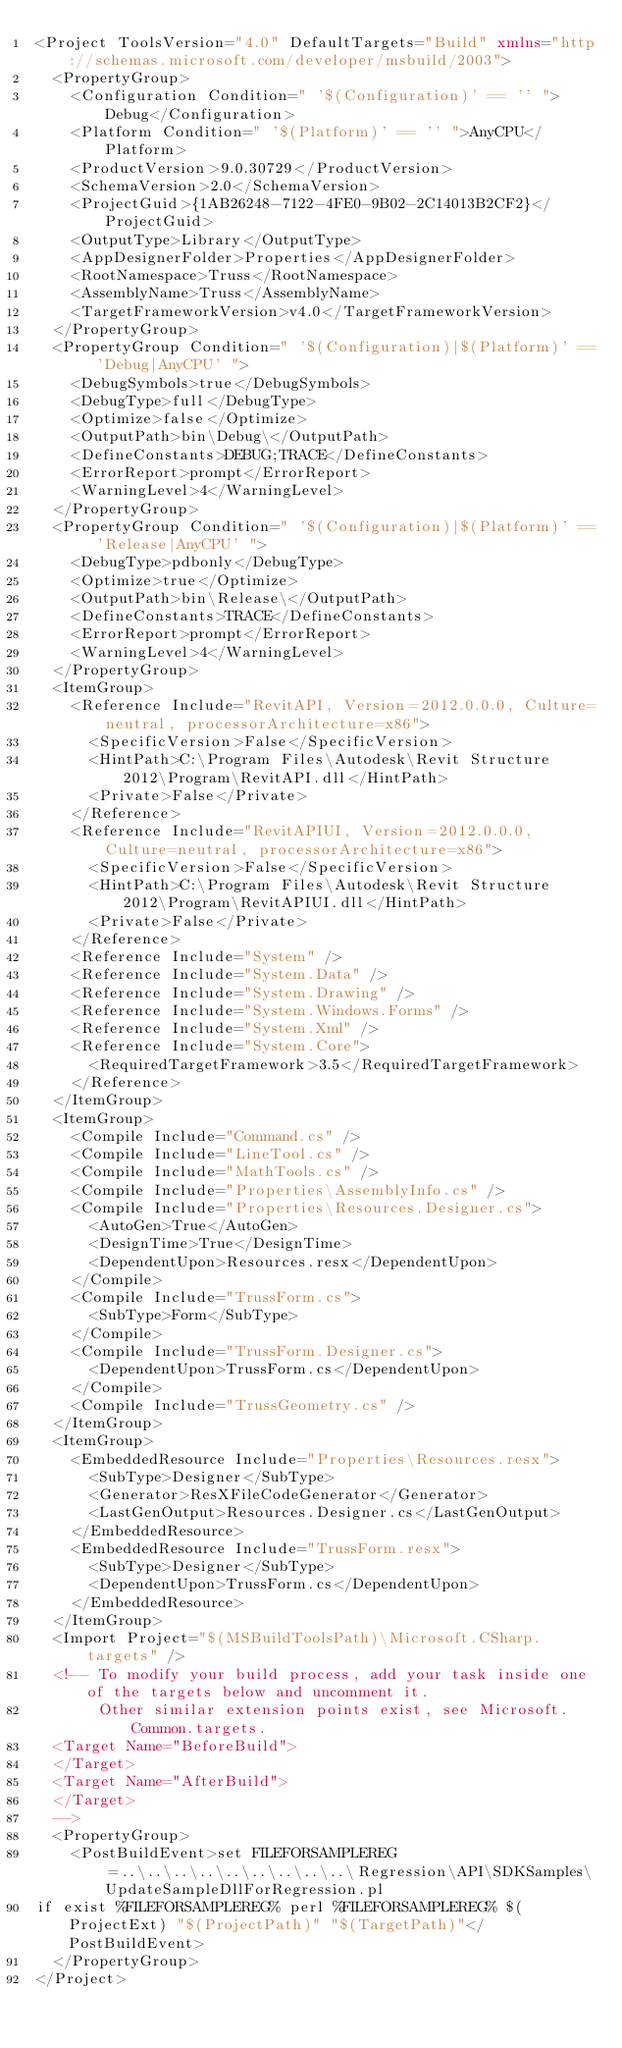Convert code to text. <code><loc_0><loc_0><loc_500><loc_500><_XML_><Project ToolsVersion="4.0" DefaultTargets="Build" xmlns="http://schemas.microsoft.com/developer/msbuild/2003">
  <PropertyGroup>
    <Configuration Condition=" '$(Configuration)' == '' ">Debug</Configuration>
    <Platform Condition=" '$(Platform)' == '' ">AnyCPU</Platform>
    <ProductVersion>9.0.30729</ProductVersion>
    <SchemaVersion>2.0</SchemaVersion>
    <ProjectGuid>{1AB26248-7122-4FE0-9B02-2C14013B2CF2}</ProjectGuid>
    <OutputType>Library</OutputType>
    <AppDesignerFolder>Properties</AppDesignerFolder>
    <RootNamespace>Truss</RootNamespace>
    <AssemblyName>Truss</AssemblyName>
    <TargetFrameworkVersion>v4.0</TargetFrameworkVersion>
  </PropertyGroup>
  <PropertyGroup Condition=" '$(Configuration)|$(Platform)' == 'Debug|AnyCPU' ">
    <DebugSymbols>true</DebugSymbols>
    <DebugType>full</DebugType>
    <Optimize>false</Optimize>
    <OutputPath>bin\Debug\</OutputPath>
    <DefineConstants>DEBUG;TRACE</DefineConstants>
    <ErrorReport>prompt</ErrorReport>
    <WarningLevel>4</WarningLevel>
  </PropertyGroup>
  <PropertyGroup Condition=" '$(Configuration)|$(Platform)' == 'Release|AnyCPU' ">
    <DebugType>pdbonly</DebugType>
    <Optimize>true</Optimize>
    <OutputPath>bin\Release\</OutputPath>
    <DefineConstants>TRACE</DefineConstants>
    <ErrorReport>prompt</ErrorReport>
    <WarningLevel>4</WarningLevel>
  </PropertyGroup>
  <ItemGroup>
    <Reference Include="RevitAPI, Version=2012.0.0.0, Culture=neutral, processorArchitecture=x86">
      <SpecificVersion>False</SpecificVersion>
      <HintPath>C:\Program Files\Autodesk\Revit Structure 2012\Program\RevitAPI.dll</HintPath>
      <Private>False</Private>
    </Reference>
    <Reference Include="RevitAPIUI, Version=2012.0.0.0, Culture=neutral, processorArchitecture=x86">
      <SpecificVersion>False</SpecificVersion>
      <HintPath>C:\Program Files\Autodesk\Revit Structure 2012\Program\RevitAPIUI.dll</HintPath>
      <Private>False</Private>
    </Reference>
    <Reference Include="System" />
    <Reference Include="System.Data" />
    <Reference Include="System.Drawing" />
    <Reference Include="System.Windows.Forms" />
    <Reference Include="System.Xml" />
    <Reference Include="System.Core">
      <RequiredTargetFramework>3.5</RequiredTargetFramework>
    </Reference>
  </ItemGroup>
  <ItemGroup>
    <Compile Include="Command.cs" />
    <Compile Include="LineTool.cs" />
    <Compile Include="MathTools.cs" />
    <Compile Include="Properties\AssemblyInfo.cs" />
    <Compile Include="Properties\Resources.Designer.cs">
      <AutoGen>True</AutoGen>
      <DesignTime>True</DesignTime>
      <DependentUpon>Resources.resx</DependentUpon>
    </Compile>
    <Compile Include="TrussForm.cs">
      <SubType>Form</SubType>
    </Compile>
    <Compile Include="TrussForm.Designer.cs">
      <DependentUpon>TrussForm.cs</DependentUpon>
    </Compile>
    <Compile Include="TrussGeometry.cs" />
  </ItemGroup>
  <ItemGroup>
    <EmbeddedResource Include="Properties\Resources.resx">
      <SubType>Designer</SubType>
      <Generator>ResXFileCodeGenerator</Generator>
      <LastGenOutput>Resources.Designer.cs</LastGenOutput>
    </EmbeddedResource>
    <EmbeddedResource Include="TrussForm.resx">
      <SubType>Designer</SubType>
      <DependentUpon>TrussForm.cs</DependentUpon>
    </EmbeddedResource>
  </ItemGroup>
  <Import Project="$(MSBuildToolsPath)\Microsoft.CSharp.targets" />
  <!-- To modify your build process, add your task inside one of the targets below and uncomment it. 
       Other similar extension points exist, see Microsoft.Common.targets.
  <Target Name="BeforeBuild">
  </Target>
  <Target Name="AfterBuild">
  </Target>
  -->
  <PropertyGroup>
    <PostBuildEvent>set FILEFORSAMPLEREG=..\..\..\..\..\..\..\..\..\Regression\API\SDKSamples\UpdateSampleDllForRegression.pl
if exist %FILEFORSAMPLEREG% perl %FILEFORSAMPLEREG% $(ProjectExt) "$(ProjectPath)" "$(TargetPath)"</PostBuildEvent>
  </PropertyGroup>
</Project>
</code> 